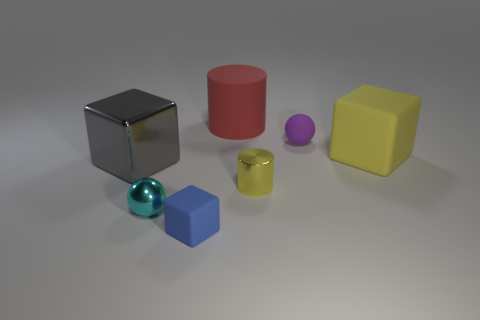What number of tiny cyan metallic balls are there?
Your answer should be compact. 1. Are there any rubber objects of the same color as the tiny metallic cylinder?
Offer a very short reply. Yes. There is a cylinder that is behind the small thing behind the big metal cube that is left of the shiny cylinder; what is its color?
Your response must be concise. Red. Does the tiny cylinder have the same material as the sphere in front of the yellow metallic cylinder?
Your response must be concise. Yes. What material is the cyan object?
Provide a short and direct response. Metal. What material is the large block that is the same color as the tiny cylinder?
Offer a very short reply. Rubber. What number of other objects are there of the same material as the gray thing?
Your answer should be compact. 2. What is the shape of the object that is to the left of the yellow metallic cylinder and to the right of the small cube?
Your response must be concise. Cylinder. There is a large thing that is the same material as the large red cylinder; what color is it?
Offer a very short reply. Yellow. Are there the same number of big red cylinders in front of the large gray cube and small purple blocks?
Give a very brief answer. Yes. 